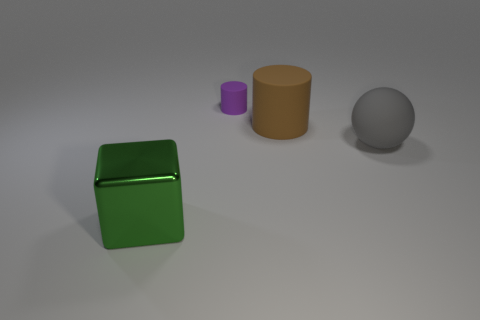Add 2 tiny brown matte spheres. How many objects exist? 6 Subtract all spheres. How many objects are left? 3 Add 3 large matte balls. How many large matte balls exist? 4 Subtract 0 green cylinders. How many objects are left? 4 Subtract all big yellow metal things. Subtract all green cubes. How many objects are left? 3 Add 2 purple rubber things. How many purple rubber things are left? 3 